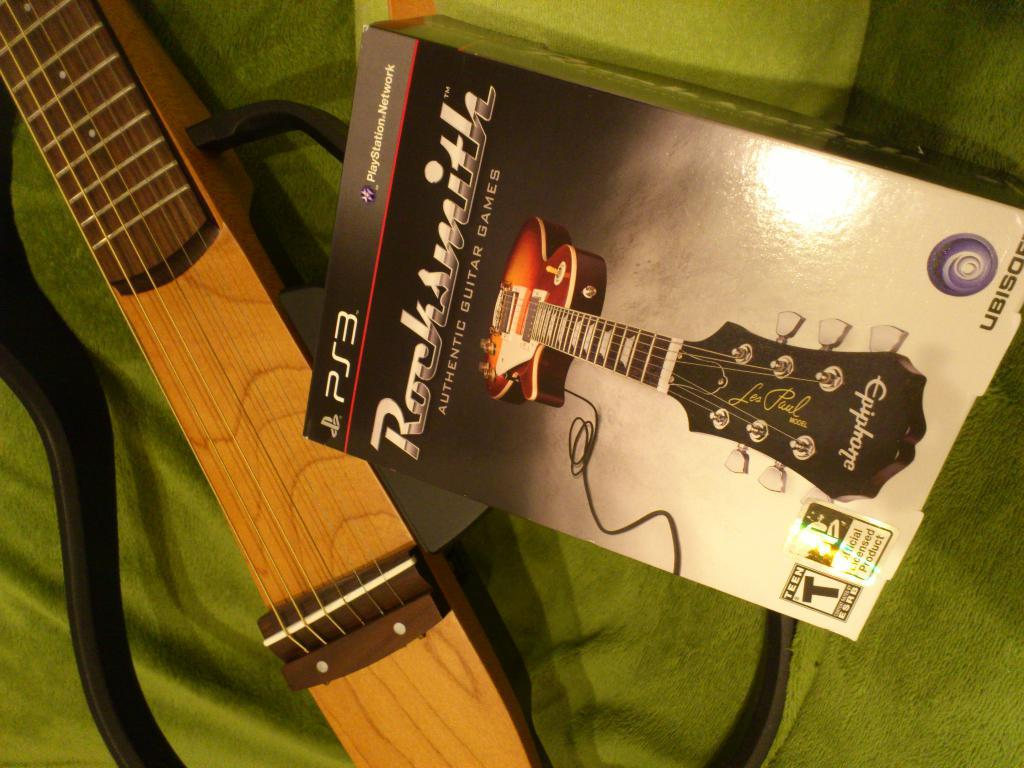<image>
Render a clear and concise summary of the photo. If you have a PS3 you can play this copy of Rocksmith. 